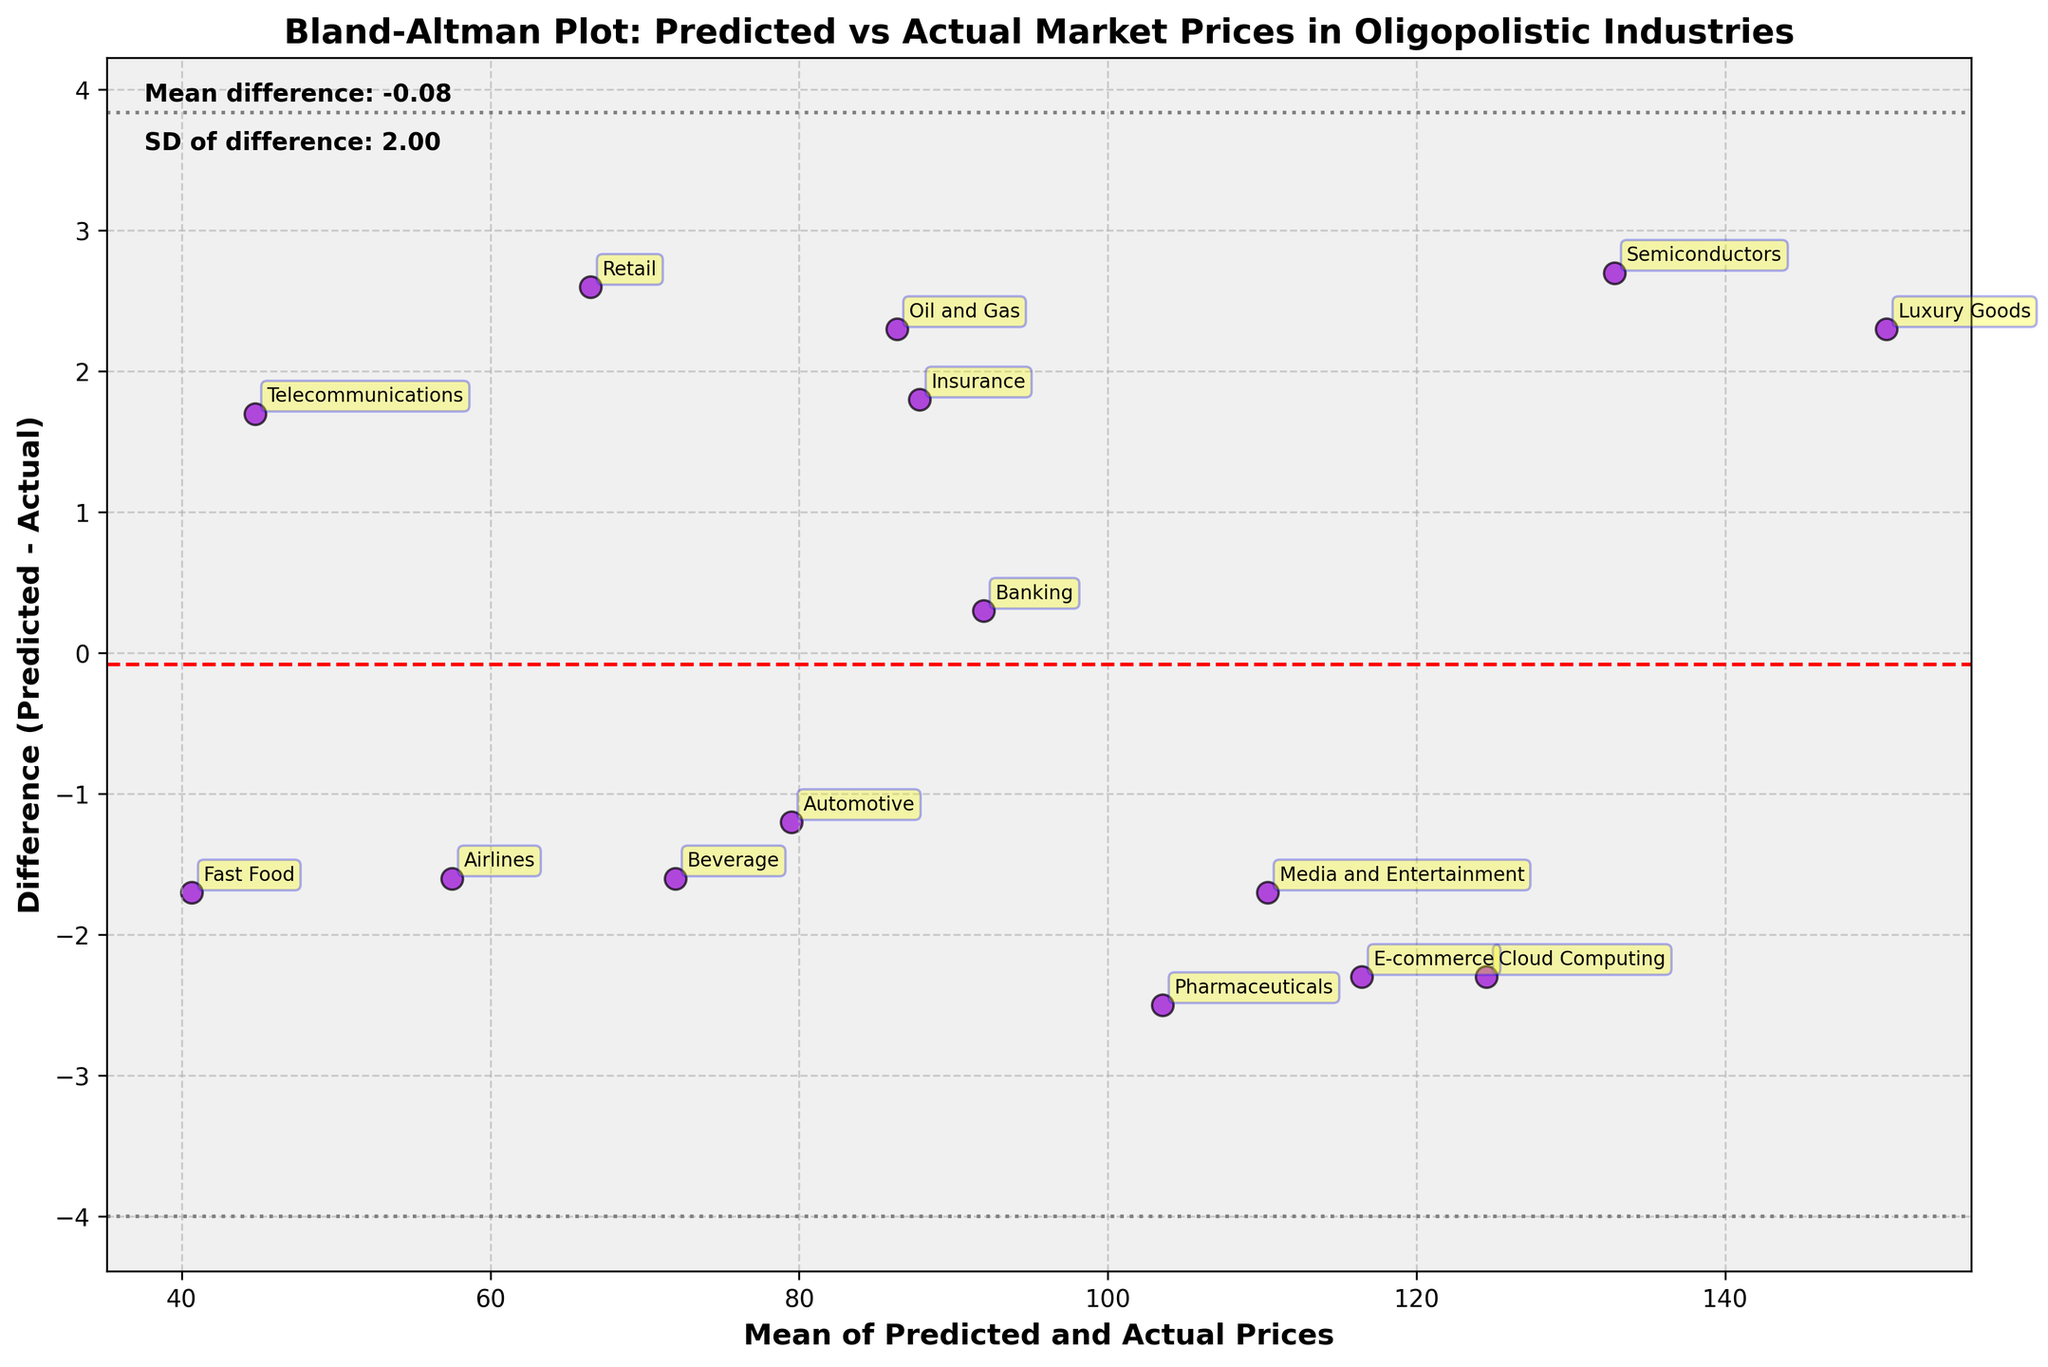What is the title of the plot? The title of the plot is displayed at the top of the figure.
Answer: Bland-Altman Plot: Predicted vs Actual Market Prices in Oligopolistic Industries What are the x-axis and y-axis labels? These labels are located next to the respective axes in the plot.
Answer: Mean of Predicted and Actual Prices (x-axis), Difference (Predicted - Actual) (y-axis) What is the mean difference between predicted and actual prices? The mean difference is annotated on the plot, usually as text within the figure.
Answer: Mean difference: 0.52 What is the standard deviation of the differences? The standard deviation of the differences is annotated on the plot as text.
Answer: SD of difference: 2.42 Which industry has the highest mean of predicted and actual prices? Look for the data point at the highest x-axis value.
Answer: Luxury Goods Which industry has the largest difference between predicted and actual prices? Identify the point farthest from the zero line on the y-axis.
Answer: Pharmaceuticals Are there more industries with predicted prices higher than actual prices or vice versa? Count the points above and below the zero line on the y-axis.
Answer: More industries have predicted prices higher than actual What is the approximate range of the x-axis values? Observe the lowest and highest x-axis values.
Answer: Approximately 42 to 143 What is the approximate range of the y-axis values? Observe the lowest and highest y-axis values.
Answer: Approximately -3 to 2.5 What do the dashed and dotted lines on the plot represent? The dashed line represents the mean difference, and the dotted lines represent the limits of agreement, which are the mean difference ± 1.96 times the standard deviation.
Answer: Mean difference, Limits of Agreement (±1.96*SD) 